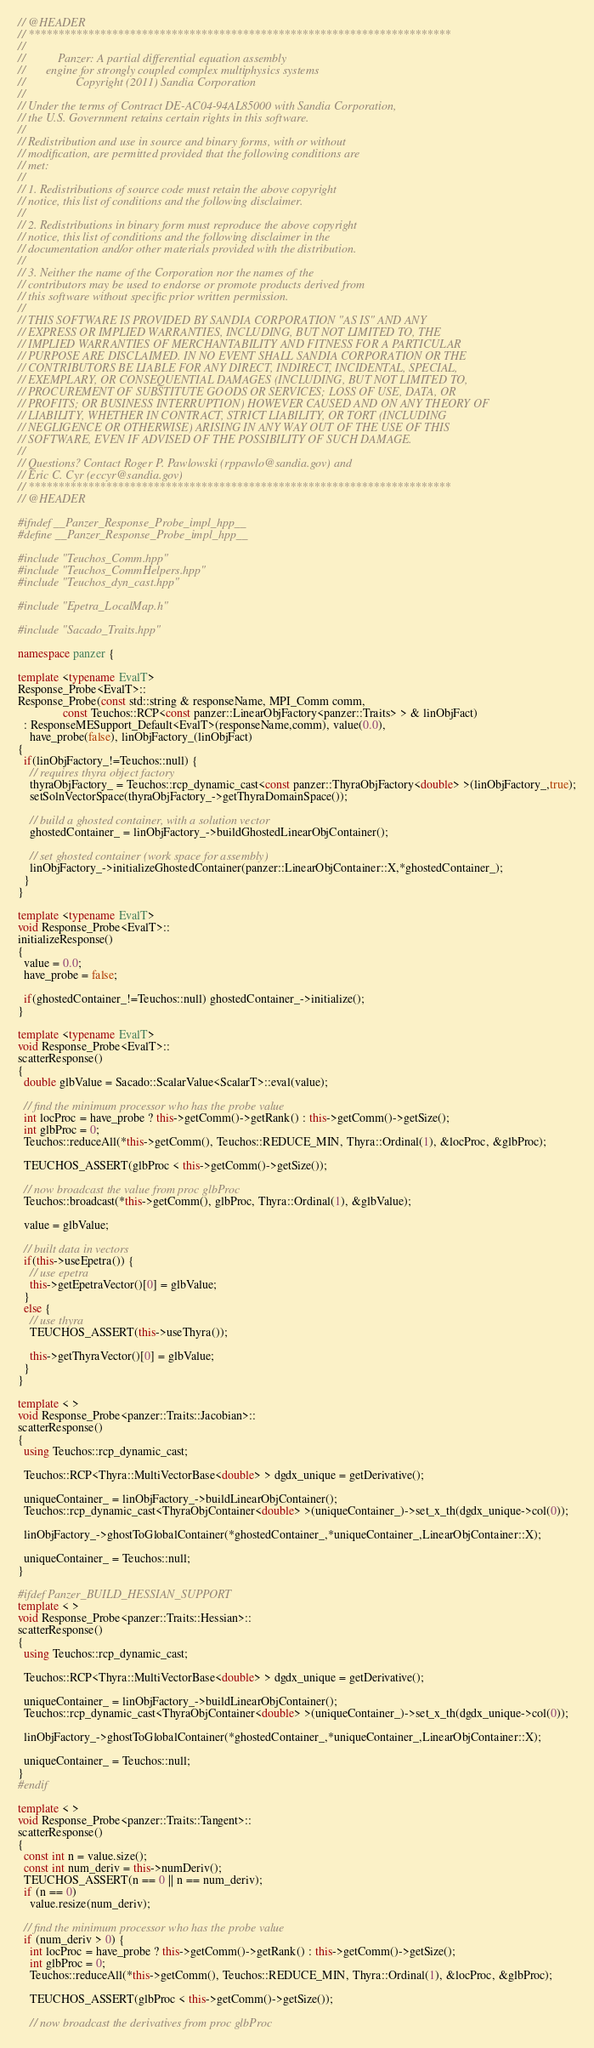<code> <loc_0><loc_0><loc_500><loc_500><_C++_>// @HEADER
// ***********************************************************************
//
//           Panzer: A partial differential equation assembly
//       engine for strongly coupled complex multiphysics systems
//                 Copyright (2011) Sandia Corporation
//
// Under the terms of Contract DE-AC04-94AL85000 with Sandia Corporation,
// the U.S. Government retains certain rights in this software.
//
// Redistribution and use in source and binary forms, with or without
// modification, are permitted provided that the following conditions are
// met:
//
// 1. Redistributions of source code must retain the above copyright
// notice, this list of conditions and the following disclaimer.
//
// 2. Redistributions in binary form must reproduce the above copyright
// notice, this list of conditions and the following disclaimer in the
// documentation and/or other materials provided with the distribution.
//
// 3. Neither the name of the Corporation nor the names of the
// contributors may be used to endorse or promote products derived from
// this software without specific prior written permission.
//
// THIS SOFTWARE IS PROVIDED BY SANDIA CORPORATION "AS IS" AND ANY
// EXPRESS OR IMPLIED WARRANTIES, INCLUDING, BUT NOT LIMITED TO, THE
// IMPLIED WARRANTIES OF MERCHANTABILITY AND FITNESS FOR A PARTICULAR
// PURPOSE ARE DISCLAIMED. IN NO EVENT SHALL SANDIA CORPORATION OR THE
// CONTRIBUTORS BE LIABLE FOR ANY DIRECT, INDIRECT, INCIDENTAL, SPECIAL,
// EXEMPLARY, OR CONSEQUENTIAL DAMAGES (INCLUDING, BUT NOT LIMITED TO,
// PROCUREMENT OF SUBSTITUTE GOODS OR SERVICES; LOSS OF USE, DATA, OR
// PROFITS; OR BUSINESS INTERRUPTION) HOWEVER CAUSED AND ON ANY THEORY OF
// LIABILITY, WHETHER IN CONTRACT, STRICT LIABILITY, OR TORT (INCLUDING
// NEGLIGENCE OR OTHERWISE) ARISING IN ANY WAY OUT OF THE USE OF THIS
// SOFTWARE, EVEN IF ADVISED OF THE POSSIBILITY OF SUCH DAMAGE.
//
// Questions? Contact Roger P. Pawlowski (rppawlo@sandia.gov) and
// Eric C. Cyr (eccyr@sandia.gov)
// ***********************************************************************
// @HEADER

#ifndef __Panzer_Response_Probe_impl_hpp__
#define __Panzer_Response_Probe_impl_hpp__

#include "Teuchos_Comm.hpp"
#include "Teuchos_CommHelpers.hpp"
#include "Teuchos_dyn_cast.hpp"

#include "Epetra_LocalMap.h"

#include "Sacado_Traits.hpp"

namespace panzer {

template <typename EvalT>
Response_Probe<EvalT>::
Response_Probe(const std::string & responseName, MPI_Comm comm,
               const Teuchos::RCP<const panzer::LinearObjFactory<panzer::Traits> > & linObjFact)
  : ResponseMESupport_Default<EvalT>(responseName,comm), value(0.0),
    have_probe(false), linObjFactory_(linObjFact)
{
  if(linObjFactory_!=Teuchos::null) {
    // requires thyra object factory
    thyraObjFactory_ = Teuchos::rcp_dynamic_cast<const panzer::ThyraObjFactory<double> >(linObjFactory_,true);
    setSolnVectorSpace(thyraObjFactory_->getThyraDomainSpace());

    // build a ghosted container, with a solution vector
    ghostedContainer_ = linObjFactory_->buildGhostedLinearObjContainer();

    // set ghosted container (work space for assembly)
    linObjFactory_->initializeGhostedContainer(panzer::LinearObjContainer::X,*ghostedContainer_);
  }
}

template <typename EvalT>
void Response_Probe<EvalT>::
initializeResponse()
{
  value = 0.0;
  have_probe = false;

  if(ghostedContainer_!=Teuchos::null) ghostedContainer_->initialize();
}

template <typename EvalT>
void Response_Probe<EvalT>::
scatterResponse()
{
  double glbValue = Sacado::ScalarValue<ScalarT>::eval(value);

  // find the minimum processor who has the probe value
  int locProc = have_probe ? this->getComm()->getRank() : this->getComm()->getSize();
  int glbProc = 0;
  Teuchos::reduceAll(*this->getComm(), Teuchos::REDUCE_MIN, Thyra::Ordinal(1), &locProc, &glbProc);

  TEUCHOS_ASSERT(glbProc < this->getComm()->getSize());

  // now broadcast the value from proc glbProc
  Teuchos::broadcast(*this->getComm(), glbProc, Thyra::Ordinal(1), &glbValue);

  value = glbValue;

  // built data in vectors
  if(this->useEpetra()) {
    // use epetra
    this->getEpetraVector()[0] = glbValue;
  }
  else {
    // use thyra
    TEUCHOS_ASSERT(this->useThyra());

    this->getThyraVector()[0] = glbValue;
  }
}

template < >
void Response_Probe<panzer::Traits::Jacobian>::
scatterResponse()
{
  using Teuchos::rcp_dynamic_cast;

  Teuchos::RCP<Thyra::MultiVectorBase<double> > dgdx_unique = getDerivative();

  uniqueContainer_ = linObjFactory_->buildLinearObjContainer();
  Teuchos::rcp_dynamic_cast<ThyraObjContainer<double> >(uniqueContainer_)->set_x_th(dgdx_unique->col(0));

  linObjFactory_->ghostToGlobalContainer(*ghostedContainer_,*uniqueContainer_,LinearObjContainer::X);

  uniqueContainer_ = Teuchos::null;
}

#ifdef Panzer_BUILD_HESSIAN_SUPPORT
template < >
void Response_Probe<panzer::Traits::Hessian>::
scatterResponse()
{
  using Teuchos::rcp_dynamic_cast;

  Teuchos::RCP<Thyra::MultiVectorBase<double> > dgdx_unique = getDerivative();

  uniqueContainer_ = linObjFactory_->buildLinearObjContainer();
  Teuchos::rcp_dynamic_cast<ThyraObjContainer<double> >(uniqueContainer_)->set_x_th(dgdx_unique->col(0));

  linObjFactory_->ghostToGlobalContainer(*ghostedContainer_,*uniqueContainer_,LinearObjContainer::X);

  uniqueContainer_ = Teuchos::null;
}
#endif

template < >
void Response_Probe<panzer::Traits::Tangent>::
scatterResponse()
{
  const int n = value.size();
  const int num_deriv = this->numDeriv();
  TEUCHOS_ASSERT(n == 0 || n == num_deriv);
  if (n == 0)
    value.resize(num_deriv);

  // find the minimum processor who has the probe value
  if (num_deriv > 0) {
    int locProc = have_probe ? this->getComm()->getRank() : this->getComm()->getSize();
    int glbProc = 0;
    Teuchos::reduceAll(*this->getComm(), Teuchos::REDUCE_MIN, Thyra::Ordinal(1), &locProc, &glbProc);

    TEUCHOS_ASSERT(glbProc < this->getComm()->getSize());

    // now broadcast the derivatives from proc glbProc</code> 